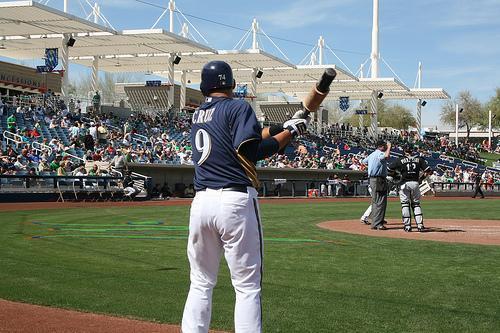How many people standing with white pants?
Give a very brief answer. 3. 